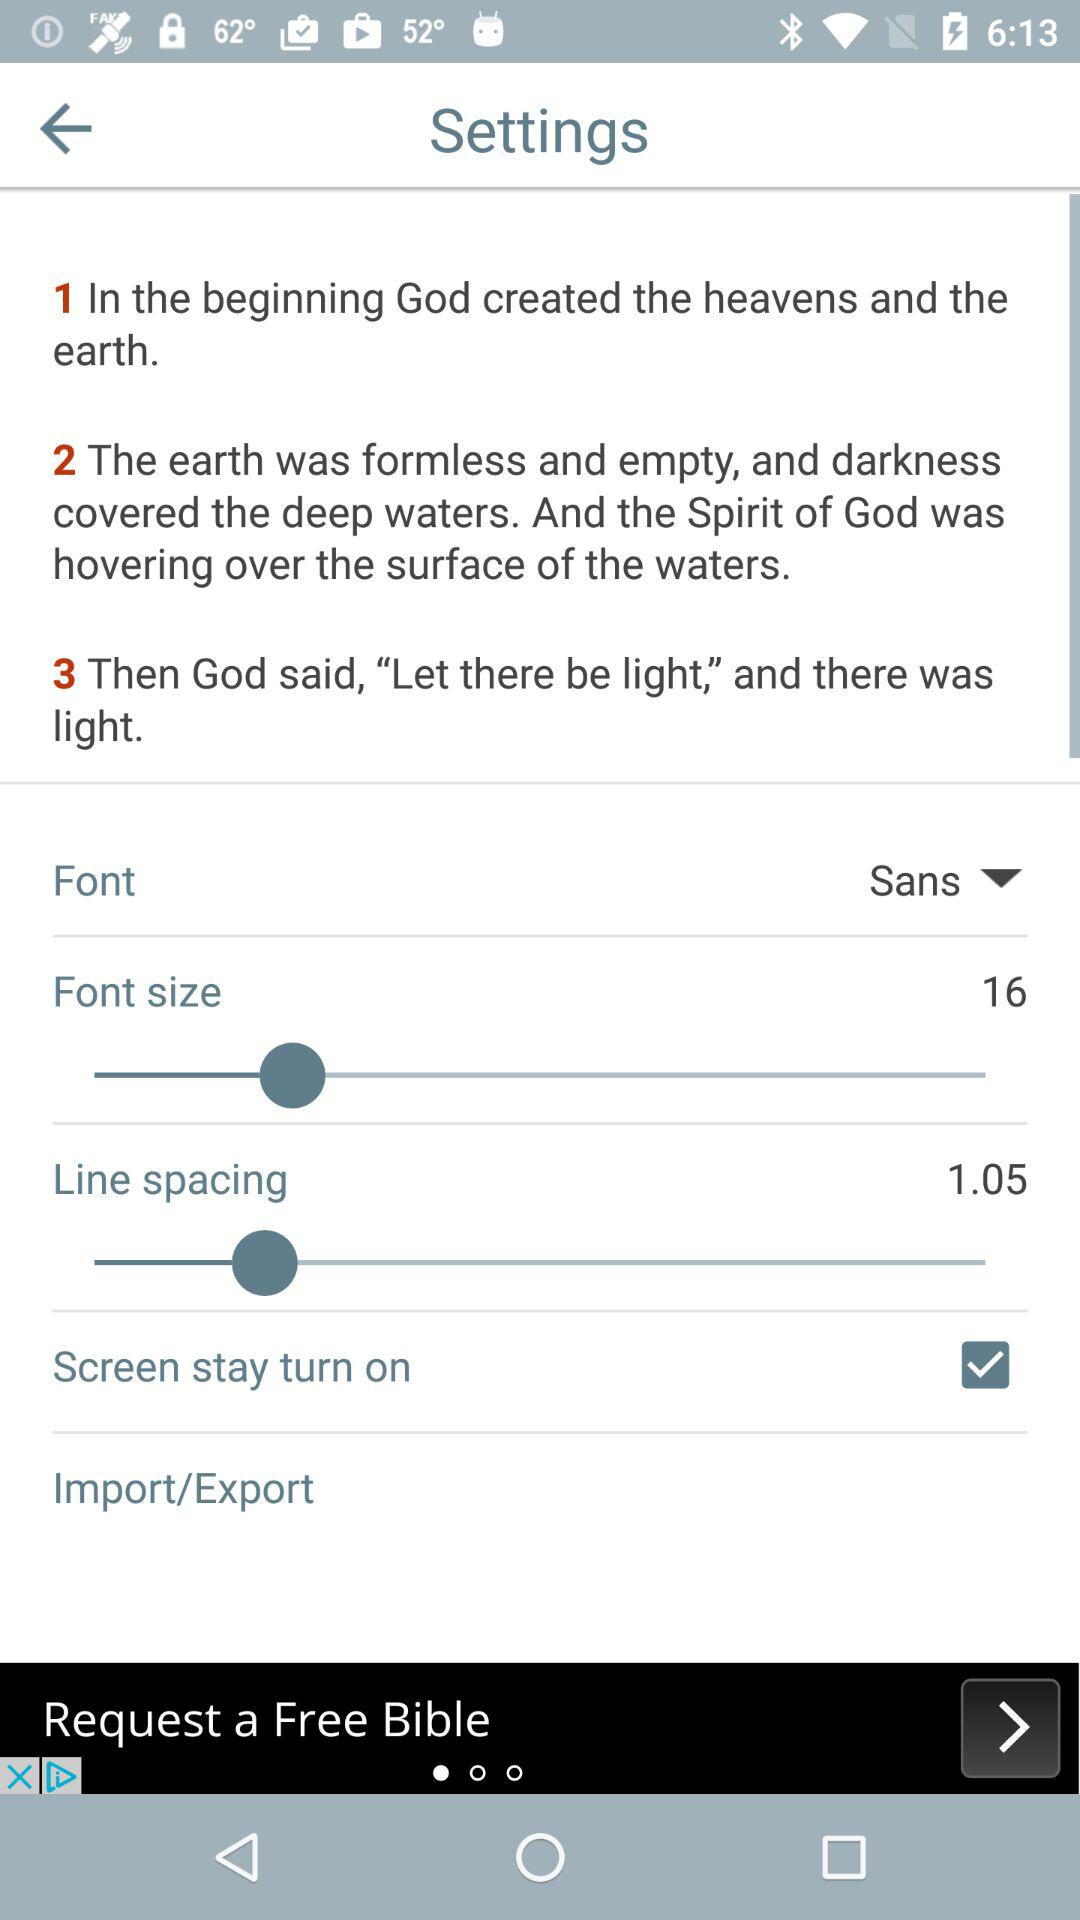Which font type was selected? The selected font size was "Sans". 